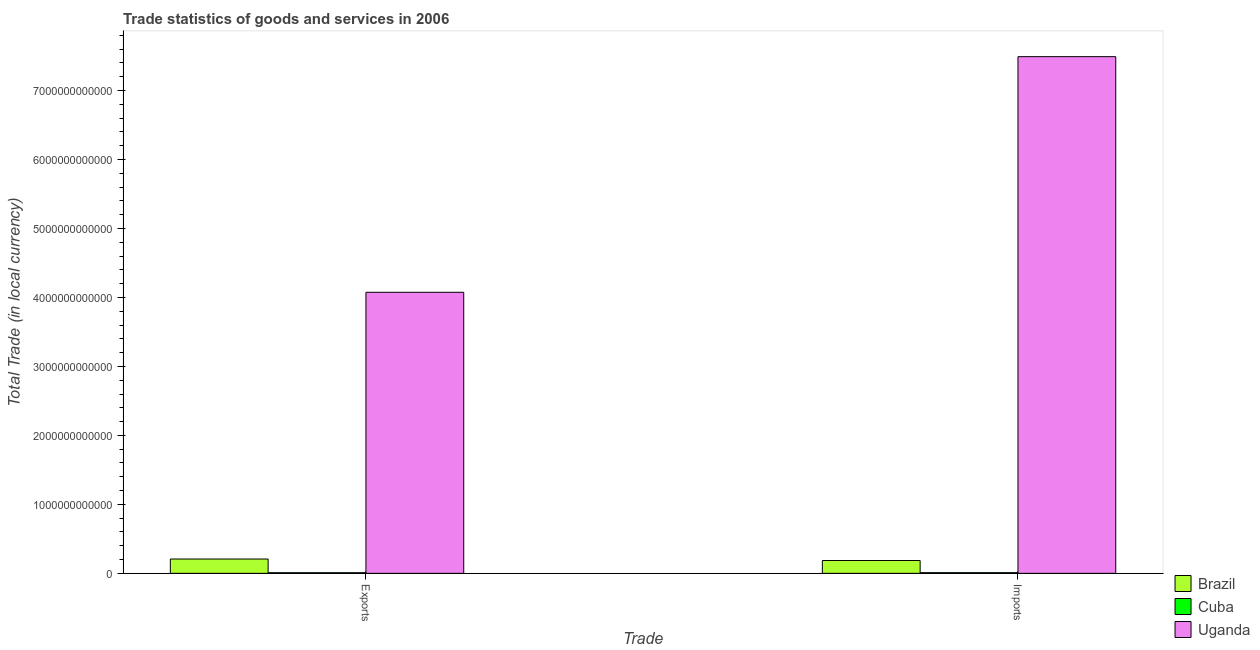How many groups of bars are there?
Offer a terse response. 2. Are the number of bars per tick equal to the number of legend labels?
Your response must be concise. Yes. What is the label of the 2nd group of bars from the left?
Ensure brevity in your answer.  Imports. What is the export of goods and services in Cuba?
Your answer should be compact. 9.08e+09. Across all countries, what is the maximum export of goods and services?
Offer a terse response. 4.08e+12. Across all countries, what is the minimum imports of goods and services?
Provide a succinct answer. 9.42e+09. In which country was the export of goods and services maximum?
Your response must be concise. Uganda. In which country was the imports of goods and services minimum?
Provide a succinct answer. Cuba. What is the total imports of goods and services in the graph?
Provide a succinct answer. 7.69e+12. What is the difference between the export of goods and services in Brazil and that in Uganda?
Your response must be concise. -3.87e+12. What is the difference between the imports of goods and services in Brazil and the export of goods and services in Uganda?
Keep it short and to the point. -3.89e+12. What is the average export of goods and services per country?
Offer a terse response. 1.43e+12. What is the difference between the export of goods and services and imports of goods and services in Uganda?
Make the answer very short. -3.42e+12. In how many countries, is the export of goods and services greater than 4000000000000 LCU?
Offer a terse response. 1. What is the ratio of the export of goods and services in Uganda to that in Brazil?
Make the answer very short. 19.63. What does the 2nd bar from the left in Exports represents?
Offer a very short reply. Cuba. What does the 1st bar from the right in Imports represents?
Ensure brevity in your answer.  Uganda. How many countries are there in the graph?
Your answer should be very brief. 3. What is the difference between two consecutive major ticks on the Y-axis?
Make the answer very short. 1.00e+12. Does the graph contain any zero values?
Offer a very short reply. No. How many legend labels are there?
Provide a short and direct response. 3. What is the title of the graph?
Your answer should be very brief. Trade statistics of goods and services in 2006. What is the label or title of the X-axis?
Your answer should be compact. Trade. What is the label or title of the Y-axis?
Give a very brief answer. Total Trade (in local currency). What is the Total Trade (in local currency) in Brazil in Exports?
Give a very brief answer. 2.08e+11. What is the Total Trade (in local currency) of Cuba in Exports?
Keep it short and to the point. 9.08e+09. What is the Total Trade (in local currency) in Uganda in Exports?
Provide a succinct answer. 4.08e+12. What is the Total Trade (in local currency) in Brazil in Imports?
Provide a succinct answer. 1.86e+11. What is the Total Trade (in local currency) of Cuba in Imports?
Your answer should be very brief. 9.42e+09. What is the Total Trade (in local currency) in Uganda in Imports?
Make the answer very short. 7.49e+12. Across all Trade, what is the maximum Total Trade (in local currency) in Brazil?
Offer a very short reply. 2.08e+11. Across all Trade, what is the maximum Total Trade (in local currency) of Cuba?
Make the answer very short. 9.42e+09. Across all Trade, what is the maximum Total Trade (in local currency) of Uganda?
Ensure brevity in your answer.  7.49e+12. Across all Trade, what is the minimum Total Trade (in local currency) of Brazil?
Provide a succinct answer. 1.86e+11. Across all Trade, what is the minimum Total Trade (in local currency) of Cuba?
Provide a short and direct response. 9.08e+09. Across all Trade, what is the minimum Total Trade (in local currency) in Uganda?
Make the answer very short. 4.08e+12. What is the total Total Trade (in local currency) of Brazil in the graph?
Offer a terse response. 3.93e+11. What is the total Total Trade (in local currency) in Cuba in the graph?
Your answer should be very brief. 1.85e+1. What is the total Total Trade (in local currency) of Uganda in the graph?
Give a very brief answer. 1.16e+13. What is the difference between the Total Trade (in local currency) of Brazil in Exports and that in Imports?
Give a very brief answer. 2.16e+1. What is the difference between the Total Trade (in local currency) in Cuba in Exports and that in Imports?
Ensure brevity in your answer.  -3.40e+08. What is the difference between the Total Trade (in local currency) of Uganda in Exports and that in Imports?
Give a very brief answer. -3.42e+12. What is the difference between the Total Trade (in local currency) in Brazil in Exports and the Total Trade (in local currency) in Cuba in Imports?
Ensure brevity in your answer.  1.98e+11. What is the difference between the Total Trade (in local currency) in Brazil in Exports and the Total Trade (in local currency) in Uganda in Imports?
Give a very brief answer. -7.28e+12. What is the difference between the Total Trade (in local currency) of Cuba in Exports and the Total Trade (in local currency) of Uganda in Imports?
Ensure brevity in your answer.  -7.48e+12. What is the average Total Trade (in local currency) of Brazil per Trade?
Keep it short and to the point. 1.97e+11. What is the average Total Trade (in local currency) in Cuba per Trade?
Keep it short and to the point. 9.25e+09. What is the average Total Trade (in local currency) of Uganda per Trade?
Offer a terse response. 5.78e+12. What is the difference between the Total Trade (in local currency) in Brazil and Total Trade (in local currency) in Cuba in Exports?
Give a very brief answer. 1.98e+11. What is the difference between the Total Trade (in local currency) of Brazil and Total Trade (in local currency) of Uganda in Exports?
Provide a succinct answer. -3.87e+12. What is the difference between the Total Trade (in local currency) in Cuba and Total Trade (in local currency) in Uganda in Exports?
Your answer should be very brief. -4.07e+12. What is the difference between the Total Trade (in local currency) in Brazil and Total Trade (in local currency) in Cuba in Imports?
Your answer should be very brief. 1.77e+11. What is the difference between the Total Trade (in local currency) of Brazil and Total Trade (in local currency) of Uganda in Imports?
Your answer should be compact. -7.31e+12. What is the difference between the Total Trade (in local currency) of Cuba and Total Trade (in local currency) of Uganda in Imports?
Your response must be concise. -7.48e+12. What is the ratio of the Total Trade (in local currency) in Brazil in Exports to that in Imports?
Provide a short and direct response. 1.12. What is the ratio of the Total Trade (in local currency) in Cuba in Exports to that in Imports?
Provide a succinct answer. 0.96. What is the ratio of the Total Trade (in local currency) of Uganda in Exports to that in Imports?
Keep it short and to the point. 0.54. What is the difference between the highest and the second highest Total Trade (in local currency) in Brazil?
Give a very brief answer. 2.16e+1. What is the difference between the highest and the second highest Total Trade (in local currency) of Cuba?
Provide a short and direct response. 3.40e+08. What is the difference between the highest and the second highest Total Trade (in local currency) in Uganda?
Provide a short and direct response. 3.42e+12. What is the difference between the highest and the lowest Total Trade (in local currency) of Brazil?
Provide a succinct answer. 2.16e+1. What is the difference between the highest and the lowest Total Trade (in local currency) in Cuba?
Your response must be concise. 3.40e+08. What is the difference between the highest and the lowest Total Trade (in local currency) of Uganda?
Your answer should be compact. 3.42e+12. 